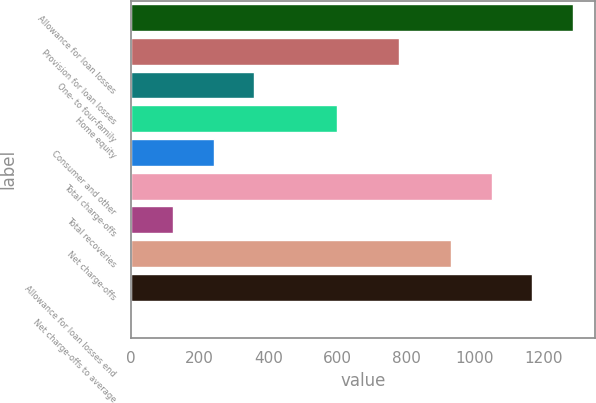Convert chart to OTSL. <chart><loc_0><loc_0><loc_500><loc_500><bar_chart><fcel>Allowance for loan losses<fcel>Provision for loan losses<fcel>One- to four-family<fcel>Home equity<fcel>Consumer and other<fcel>Total charge-offs<fcel>Total recoveries<fcel>Net charge-offs<fcel>Allowance for loan losses end<fcel>Net charge-offs to average<nl><fcel>1284.18<fcel>779.4<fcel>358.38<fcel>600<fcel>240.62<fcel>1048.66<fcel>122.86<fcel>930.9<fcel>1166.42<fcel>5.1<nl></chart> 